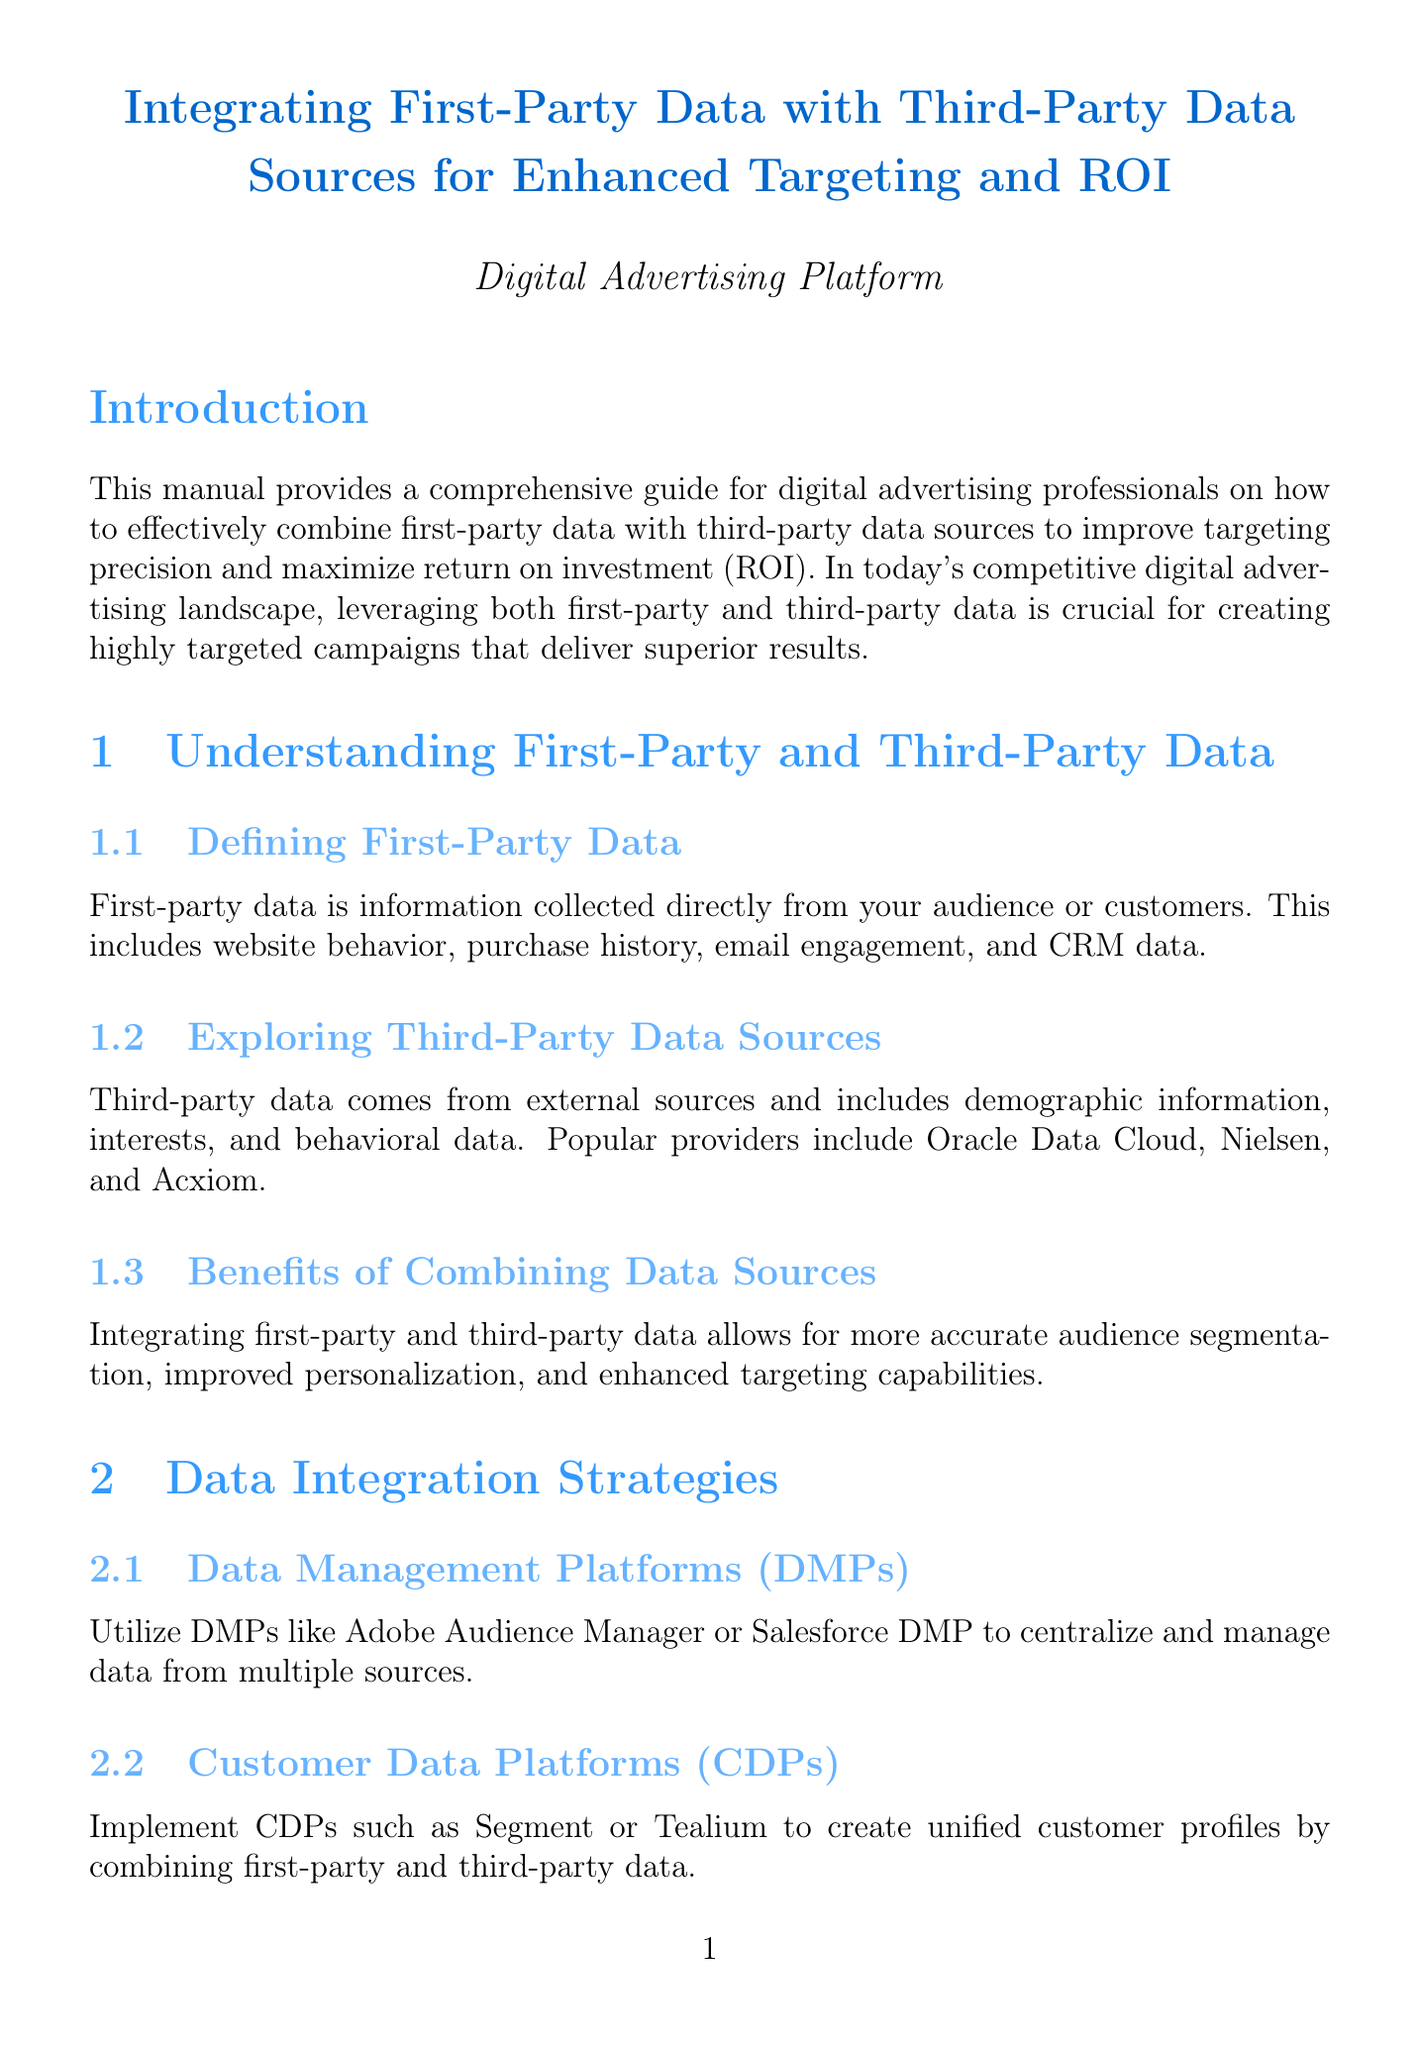What is the manual's title? The title is stated at the beginning of the document and is focused on integrating first-party and third-party data.
Answer: Integrating First-Party Data with Third-Party Data Sources for Enhanced Targeting and ROI What platforms are suggested for Data Management Platforms? The document lists specific companies that provide Data Management Platforms as part of the strategies discussed.
Answer: Adobe Audience Manager or Salesforce DMP What technique is used for creating lookalike audiences? Lookalike modeling is a specific technique mentioned for targeting audiences using combined data.
Answer: Lookalike Modeling Which compliance requirement is related to California residents' data? The manual describes regulations regarding data handling, particularly relevant for California residents.
Answer: CCPA Compliance What type of analytics tools are recommended for ROI analysis? The document suggests specific tools for analyzing ROI related to integrated data targeting.
Answer: Datorama or Tableau What is one benefit of combining first-party and third-party data? The manual outlines how data integration can enhance targeting abilities, offering specific advantages.
Answer: Enhanced targeting capabilities Which chapter discusses privacy and compliance concerns? A specific chapter is dedicated to addressing privacy and compliance considerations in digital advertising.
Answer: Privacy and Compliance Considerations What is the main purpose of implementing a Customer Data Platform (CDP)? The function of a CDP is identified concerning customer data integration strategies in the manual.
Answer: Create unified customer profiles 